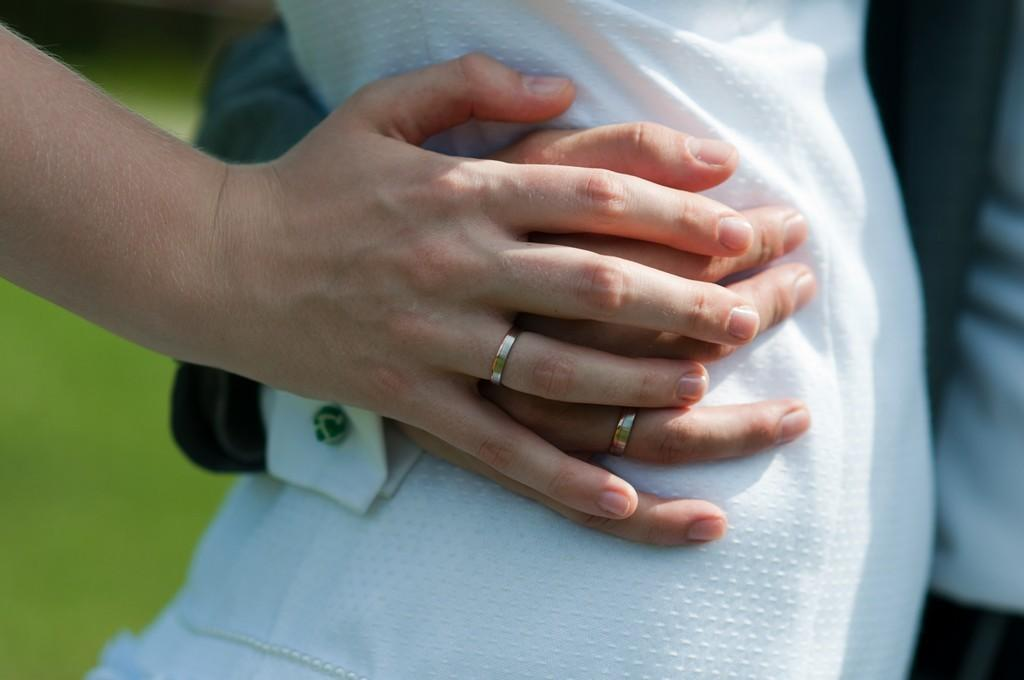What is the main subject of the image? The main subject of the image is two persons' hands in the center. Can you describe the position or interaction of the hands? Unfortunately, the provided facts do not give any information about the position or interaction of the hands. How many feathers can be seen on the hands in the image? There are no feathers present on the hands in the image. What type of snails are crawling on the hands in the image? There are no snails present on the hands in the image. 